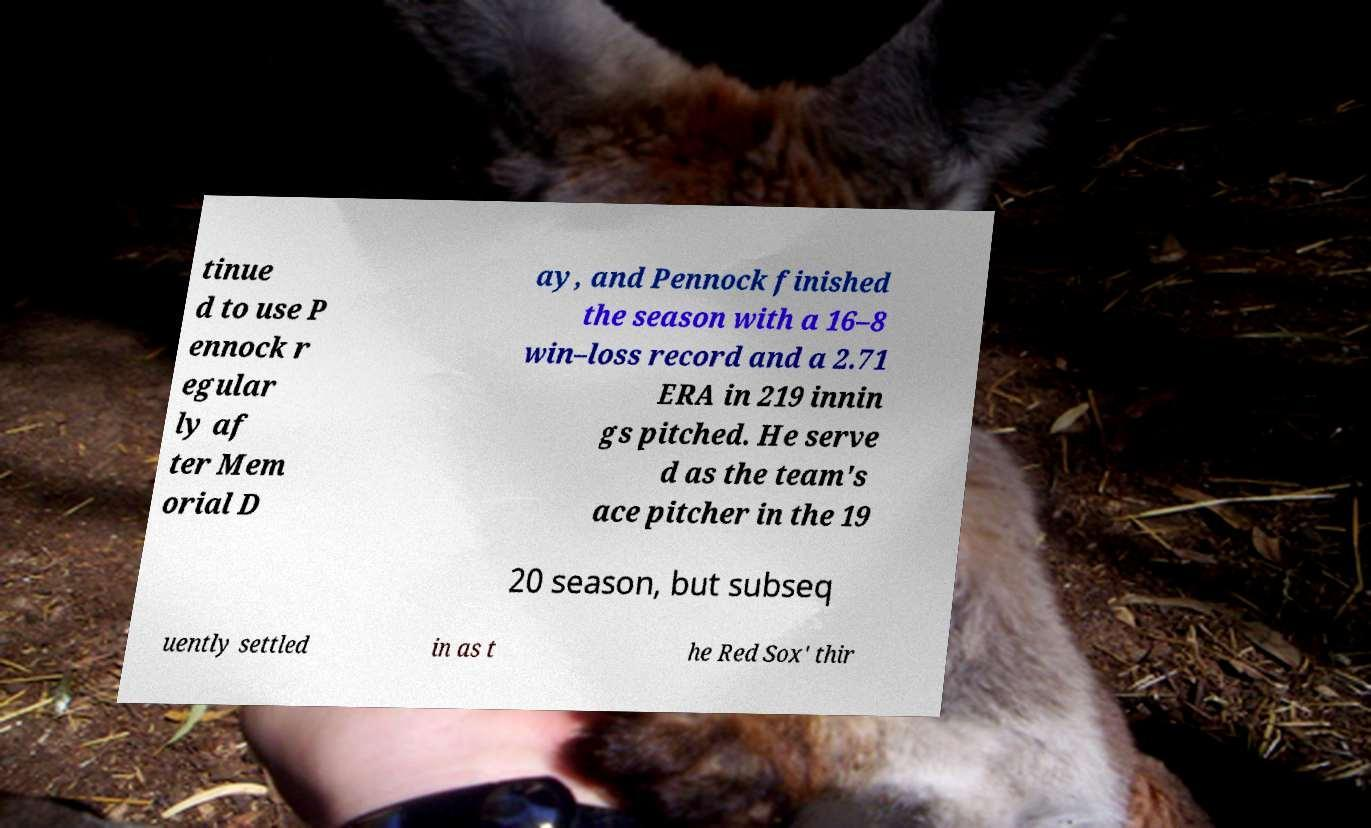Can you read and provide the text displayed in the image?This photo seems to have some interesting text. Can you extract and type it out for me? tinue d to use P ennock r egular ly af ter Mem orial D ay, and Pennock finished the season with a 16–8 win–loss record and a 2.71 ERA in 219 innin gs pitched. He serve d as the team's ace pitcher in the 19 20 season, but subseq uently settled in as t he Red Sox' thir 